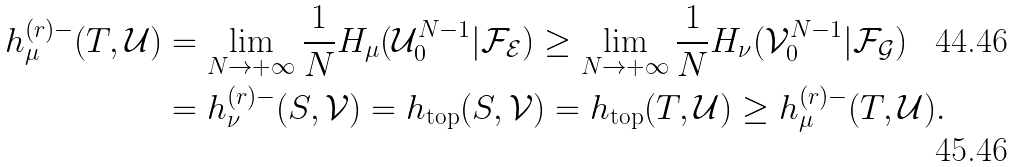Convert formula to latex. <formula><loc_0><loc_0><loc_500><loc_500>h _ { \mu } ^ { ( r ) - } ( T , \mathcal { U } ) & = \lim _ { N \rightarrow + \infty } \frac { 1 } { N } H _ { \mu } ( \mathcal { U } _ { 0 } ^ { N - 1 } | \mathcal { F } _ { \mathcal { E } } ) \geq \lim _ { N \rightarrow + \infty } \frac { 1 } { N } H _ { \nu } ( \mathcal { V } _ { 0 } ^ { N - 1 } | \mathcal { F } _ { \mathcal { G } } ) \\ & = h _ { \nu } ^ { ( r ) - } ( S , \mathcal { V } ) = h _ { \text {top} } ( S , \mathcal { V } ) = h _ { \text {top} } ( T , \mathcal { U } ) \geq h _ { \mu } ^ { ( r ) - } ( T , \mathcal { U } ) .</formula> 